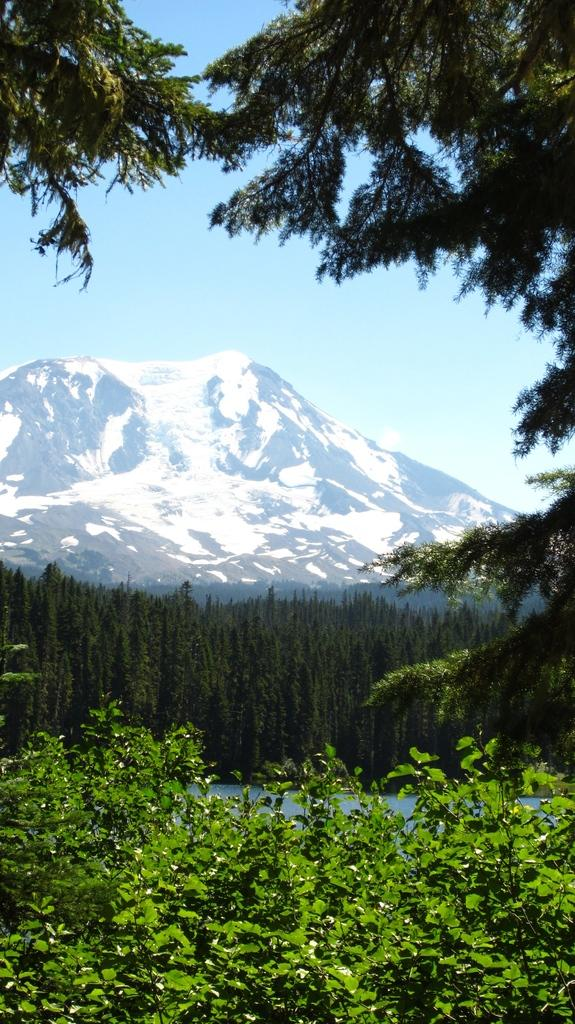What is the main feature in the center of the image? There is a hill in the center of the image. What can be seen at the bottom of the image? There are trees and plants at the bottom of the image. What is visible at the top of the image? The sky is visible at the top of the image. How many centimeters tall are the flowers in the image? There are no flowers present in the image, so it is not possible to determine their height. 